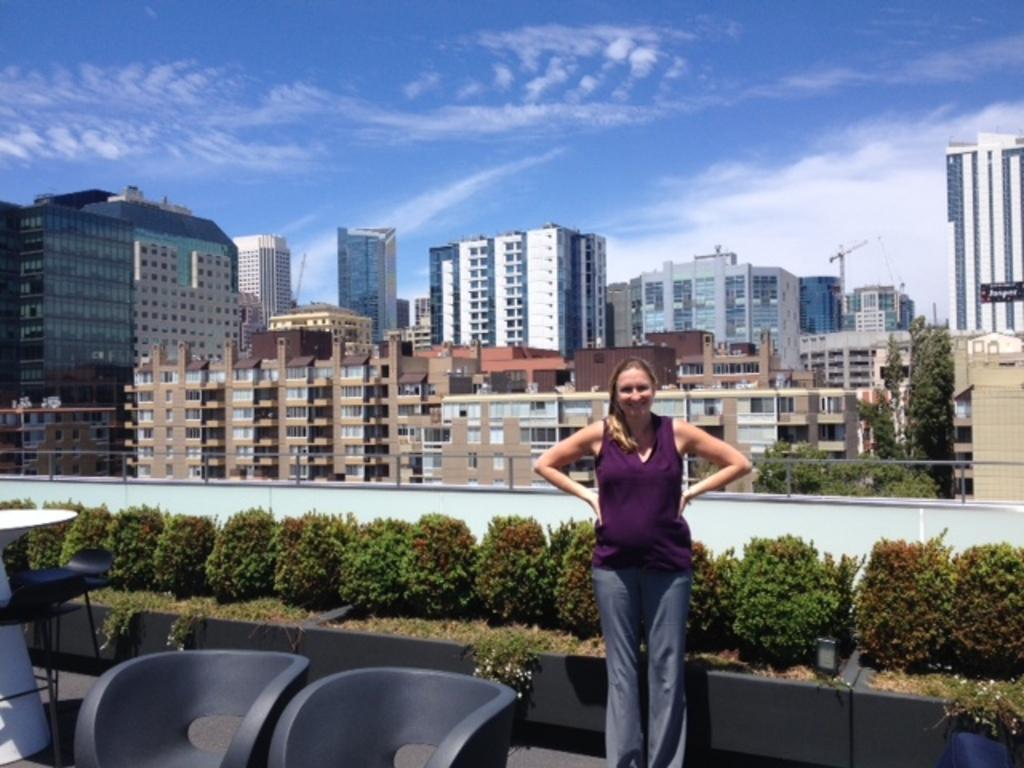Please provide a concise description of this image. At the bottom of the image there are two chairs. And there is a lady standing and smiling. Behind her there are potted plants. Behind them there is a railing. In the background there are buildings and also there are trees. At the top of the image there is sky. On the left side of the image there is a table. 